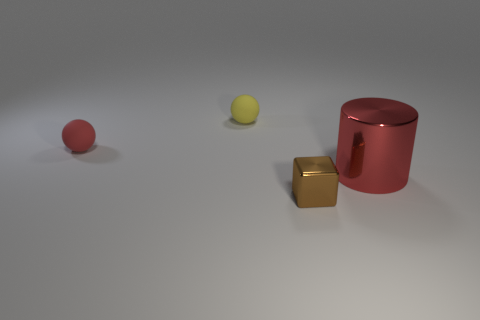Add 4 big red metallic things. How many objects exist? 8 Subtract all blocks. How many objects are left? 3 Add 4 brown matte blocks. How many brown matte blocks exist? 4 Subtract 1 red cylinders. How many objects are left? 3 Subtract all large blue cylinders. Subtract all small brown metallic things. How many objects are left? 3 Add 1 small yellow rubber balls. How many small yellow rubber balls are left? 2 